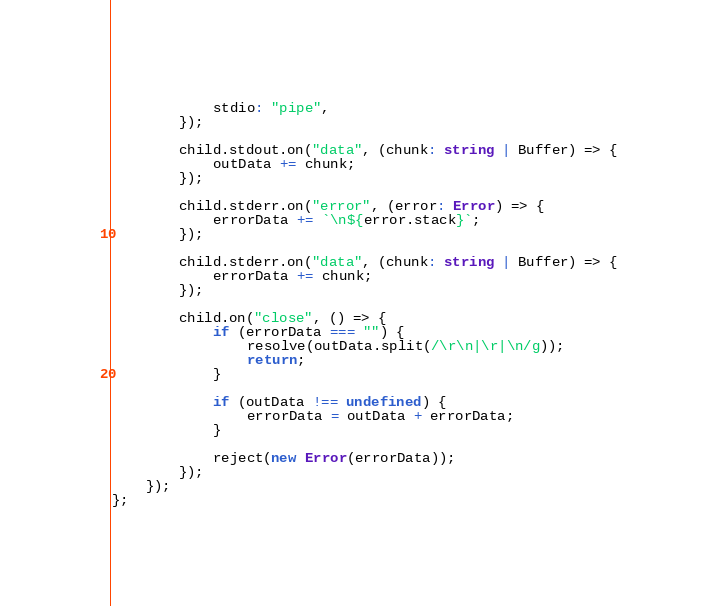Convert code to text. <code><loc_0><loc_0><loc_500><loc_500><_TypeScript_>            stdio: "pipe",
        });

        child.stdout.on("data", (chunk: string | Buffer) => {
            outData += chunk;
        });

        child.stderr.on("error", (error: Error) => {
            errorData += `\n${error.stack}`;
        });

        child.stderr.on("data", (chunk: string | Buffer) => {
            errorData += chunk;
        });

        child.on("close", () => {
            if (errorData === "") {
                resolve(outData.split(/\r\n|\r|\n/g));
                return;
            }

            if (outData !== undefined) {
                errorData = outData + errorData;
            }

            reject(new Error(errorData));
        });
    });
};
</code> 